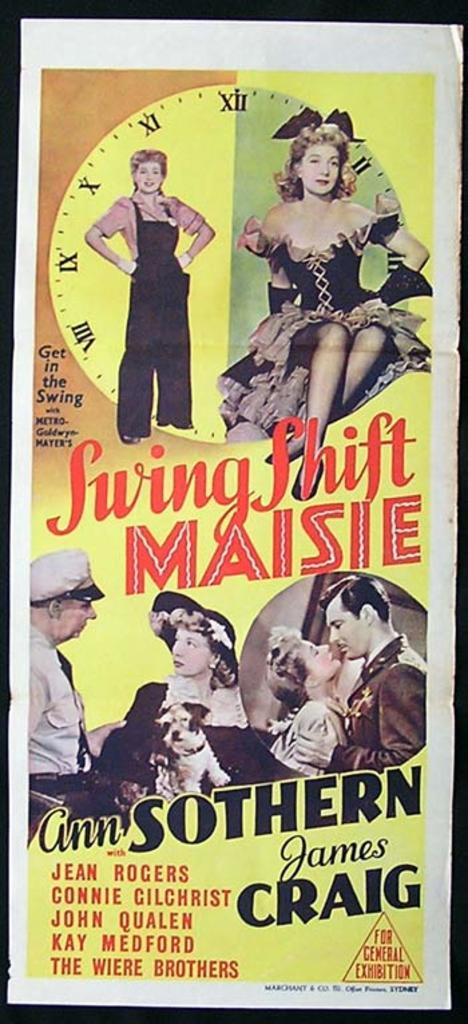Provide a one-sentence caption for the provided image. A movie poster for Swing Shift Maisie features photos of Ann Sothern and James Craig. 